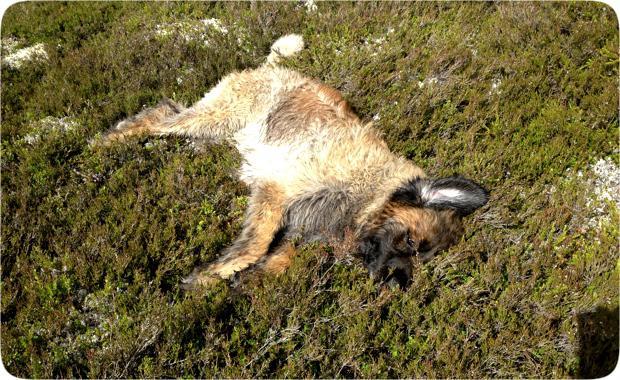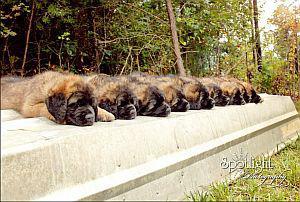The first image is the image on the left, the second image is the image on the right. Evaluate the accuracy of this statement regarding the images: "The single dog in the left image appears to be lying down.". Is it true? Answer yes or no. Yes. The first image is the image on the left, the second image is the image on the right. For the images displayed, is the sentence "All of the dogs are outside and some of them are sleeping." factually correct? Answer yes or no. Yes. 